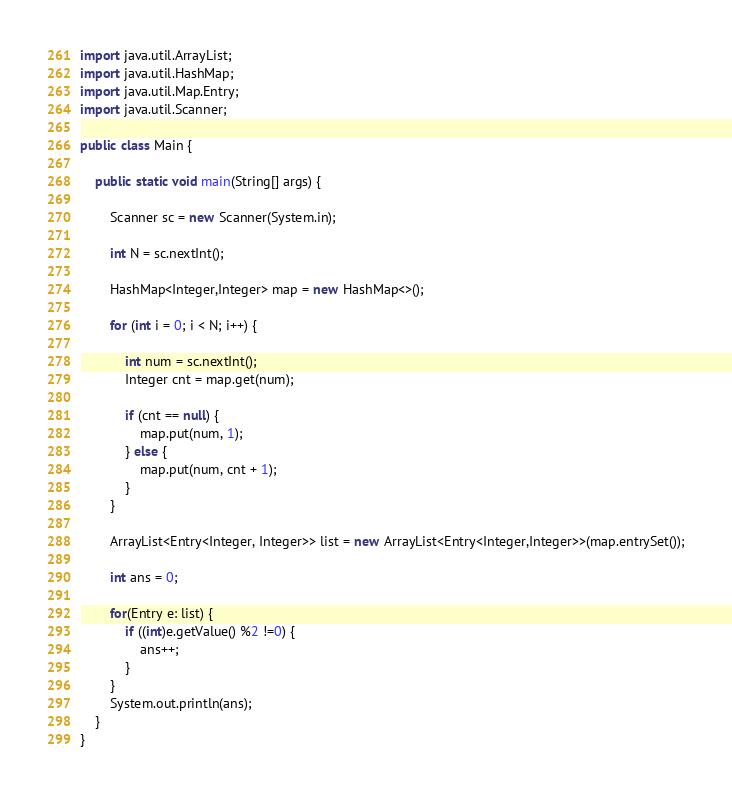<code> <loc_0><loc_0><loc_500><loc_500><_Java_>import java.util.ArrayList;
import java.util.HashMap;
import java.util.Map.Entry;
import java.util.Scanner;

public class Main {

	public static void main(String[] args) {

		Scanner sc = new Scanner(System.in);

		int N = sc.nextInt();

		HashMap<Integer,Integer> map = new HashMap<>();

		for (int i = 0; i < N; i++) {

			int num = sc.nextInt();
			Integer cnt = map.get(num);

			if (cnt == null) {
				map.put(num, 1);
			} else {
				map.put(num, cnt + 1);
			}
		}

		ArrayList<Entry<Integer, Integer>> list = new ArrayList<Entry<Integer,Integer>>(map.entrySet());

		int ans = 0;

		for(Entry e: list) {
			if ((int)e.getValue() %2 !=0) {
				ans++;
			}
		}
		System.out.println(ans);
	}
}
</code> 